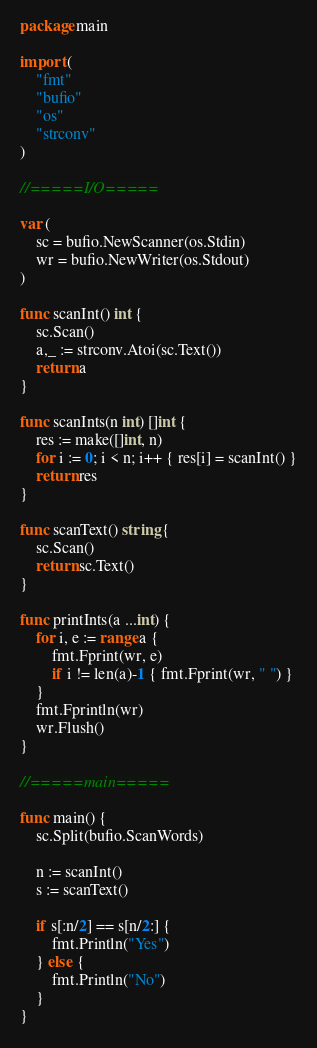<code> <loc_0><loc_0><loc_500><loc_500><_Go_>package main

import (
	"fmt"
	"bufio"
	"os"
	"strconv"
)

//=====I/O=====

var (
	sc = bufio.NewScanner(os.Stdin)
	wr = bufio.NewWriter(os.Stdout)
)

func scanInt() int {
	sc.Scan()
	a,_ := strconv.Atoi(sc.Text())
	return a
}

func scanInts(n int) []int {
	res := make([]int, n)
	for i := 0; i < n; i++ { res[i] = scanInt() }
	return res
}

func scanText() string {
	sc.Scan()
	return sc.Text()
}

func printInts(a ...int) {
	for i, e := range a {
		fmt.Fprint(wr, e)
		if i != len(a)-1 { fmt.Fprint(wr, " ") }
	}
	fmt.Fprintln(wr)
	wr.Flush()
}

//=====main=====

func main() {
	sc.Split(bufio.ScanWords)

	n := scanInt()
	s := scanText()

	if s[:n/2] == s[n/2:] {
		fmt.Println("Yes")
	} else {
		fmt.Println("No")
	}
}
</code> 